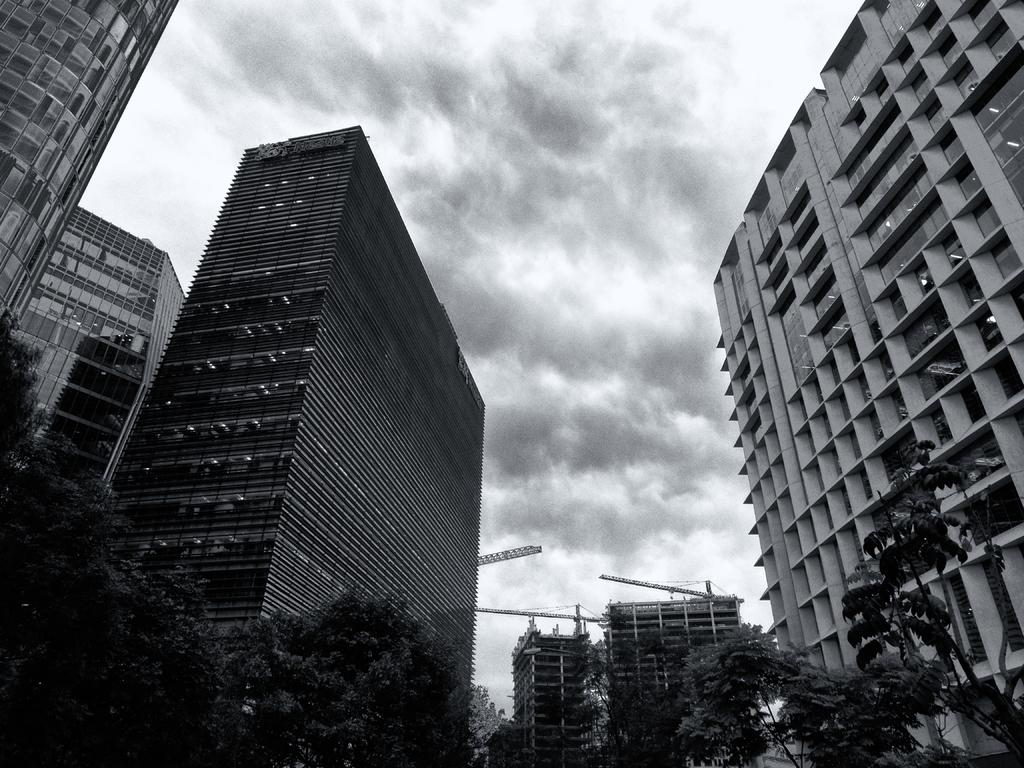What types of structures are present in the image? There are buildings in the image. What other natural elements can be seen in the image? There are trees in the image. What is visible in the background of the image? The sky is visible in the image. How much debt is owed by the stove in the image? There is no stove present in the image, so it is not possible to determine any debt owed by a stove. 